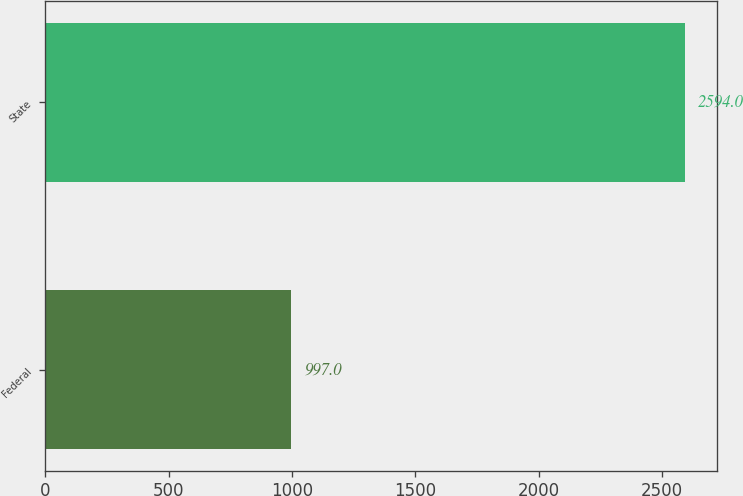Convert chart. <chart><loc_0><loc_0><loc_500><loc_500><bar_chart><fcel>Federal<fcel>State<nl><fcel>997<fcel>2594<nl></chart> 